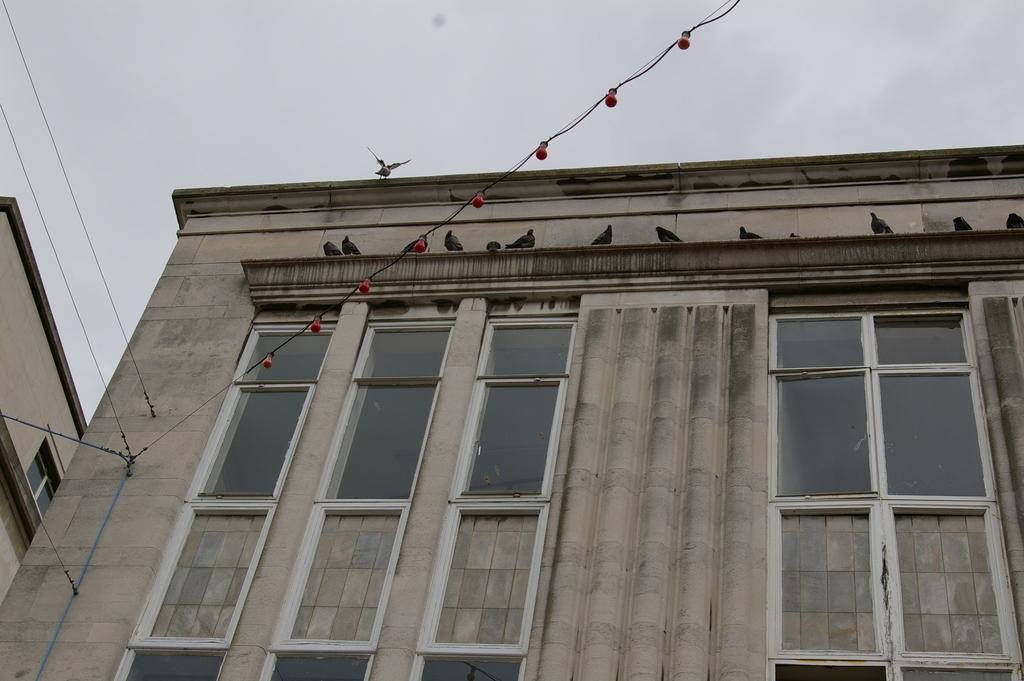What is the main subject of the image? The main subject of the image is a building. What features can be observed on the building? The building has windows and glass elements. Are there any living creatures near the building? Yes, birds are present near the building. What is the structure associated with the building? There is a wall associated with the building. What can be seen on the left side of the image? On the left side of the image, there are cables and additional buildings. Are birds visible on the left side of the image? Yes, birds are visible on the left side of the image. What part of the natural environment is visible in the image? The sky is visible in the image. What type of cakes are being served in the image? There are no cakes present in the image. Can you identify any veins in the image? There are no veins visible in the image. What religious symbols can be seen in the image? There are no religious symbols present in the image. 